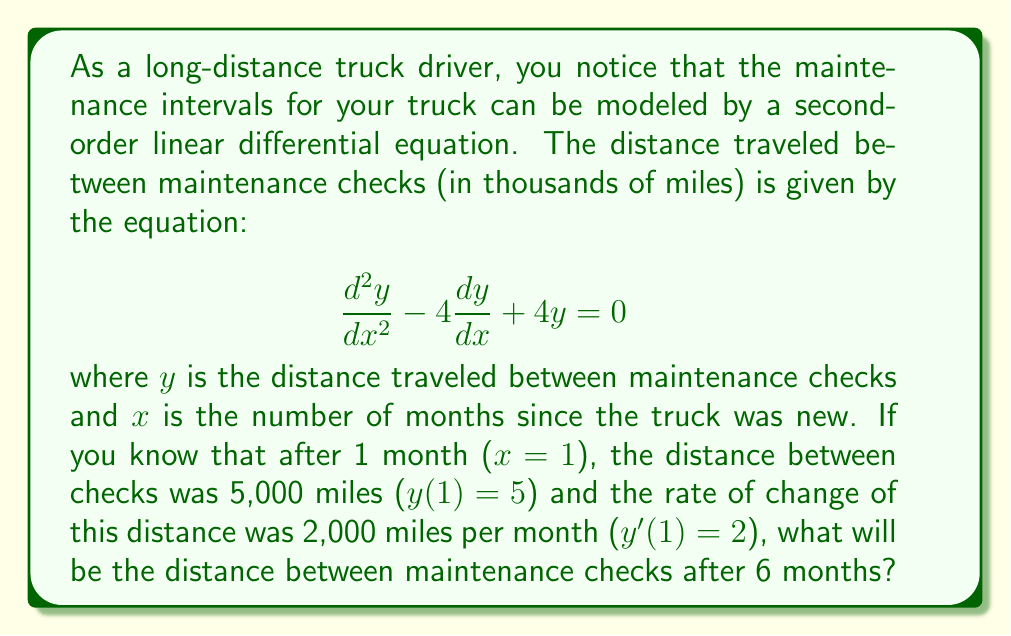Give your solution to this math problem. To solve this problem, we need to follow these steps:

1) The general solution for this second-order linear differential equation is:
   $$y = (C_1 + C_2x)e^{2x}$$

2) We need to find $C_1$ and $C_2$ using the initial conditions:
   $y(1) = 5$ and $y'(1) = 2$

3) Let's start with $y(1) = 5$:
   $$5 = (C_1 + C_2)e^2$$

4) Now, let's find $y'(x)$:
   $$y' = (C_2 + 2C_1 + 2C_2x)e^{2x}$$

5) Using $y'(1) = 2$:
   $$2 = (C_2 + 2C_1 + 2C_2)e^2$$

6) From step 3, we can say:
   $$C_1 + C_2 = 5e^{-2}$$

7) From step 5:
   $$C_2 + 2C_1 + 2C_2 = 2e^{-2}$$
   $$2C_1 + 3C_2 = 2e^{-2}$$

8) Now we have a system of two equations:
   $$C_1 + C_2 = 5e^{-2}$$
   $$2C_1 + 3C_2 = 2e^{-2}$$

9) Solving this system:
   $$C_1 = 8e^{-2}$$
   $$C_2 = -3e^{-2}$$

10) Therefore, the particular solution is:
    $$y = (8e^{-2} - 3e^{-2}x)e^{2x}$$

11) Simplifying:
    $$y = 8 - 3x$$

12) To find the distance after 6 months, we substitute $x=6$:
    $$y(6) = 8 - 3(6) = 8 - 18 = -10$$

13) Since distance can't be negative, we take the absolute value. Also, remember that $y$ was in thousands of miles.

Therefore, after 6 months, the distance between maintenance checks will be 10,000 miles.
Answer: 10,000 miles 